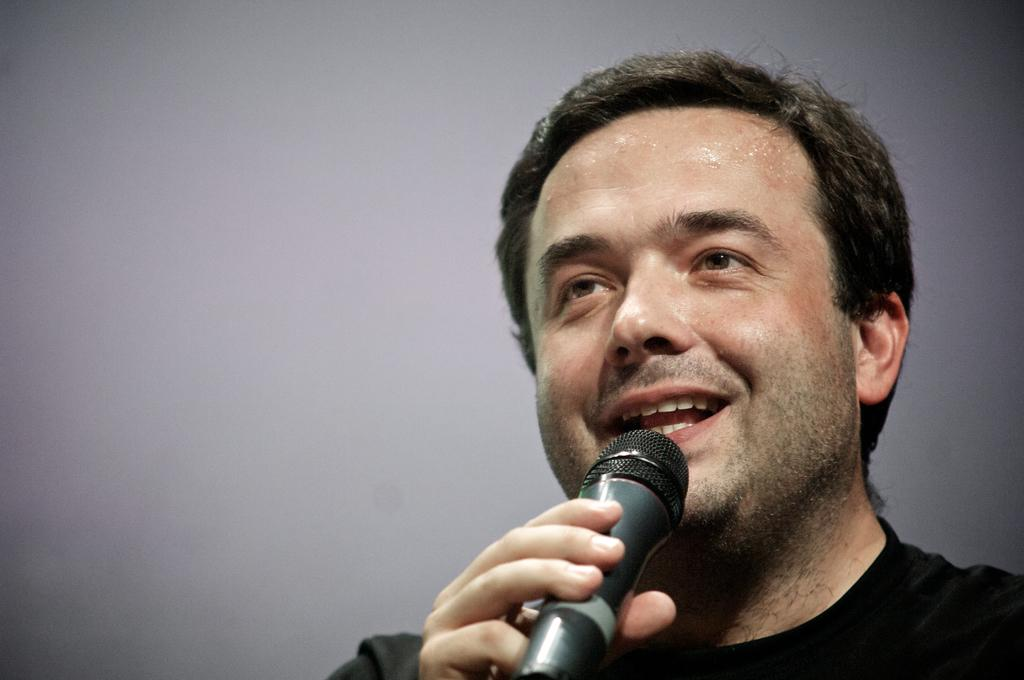What is the main subject of the image? The main subject of the image is a man. What is the man doing in the image? The man is talking on a mike. What type of drug is the man using in the image? There is no drug present in the image; the man is talking on a mike. What game is the man playing in the image? There is no game present in the image; the man is talking on a mike. 